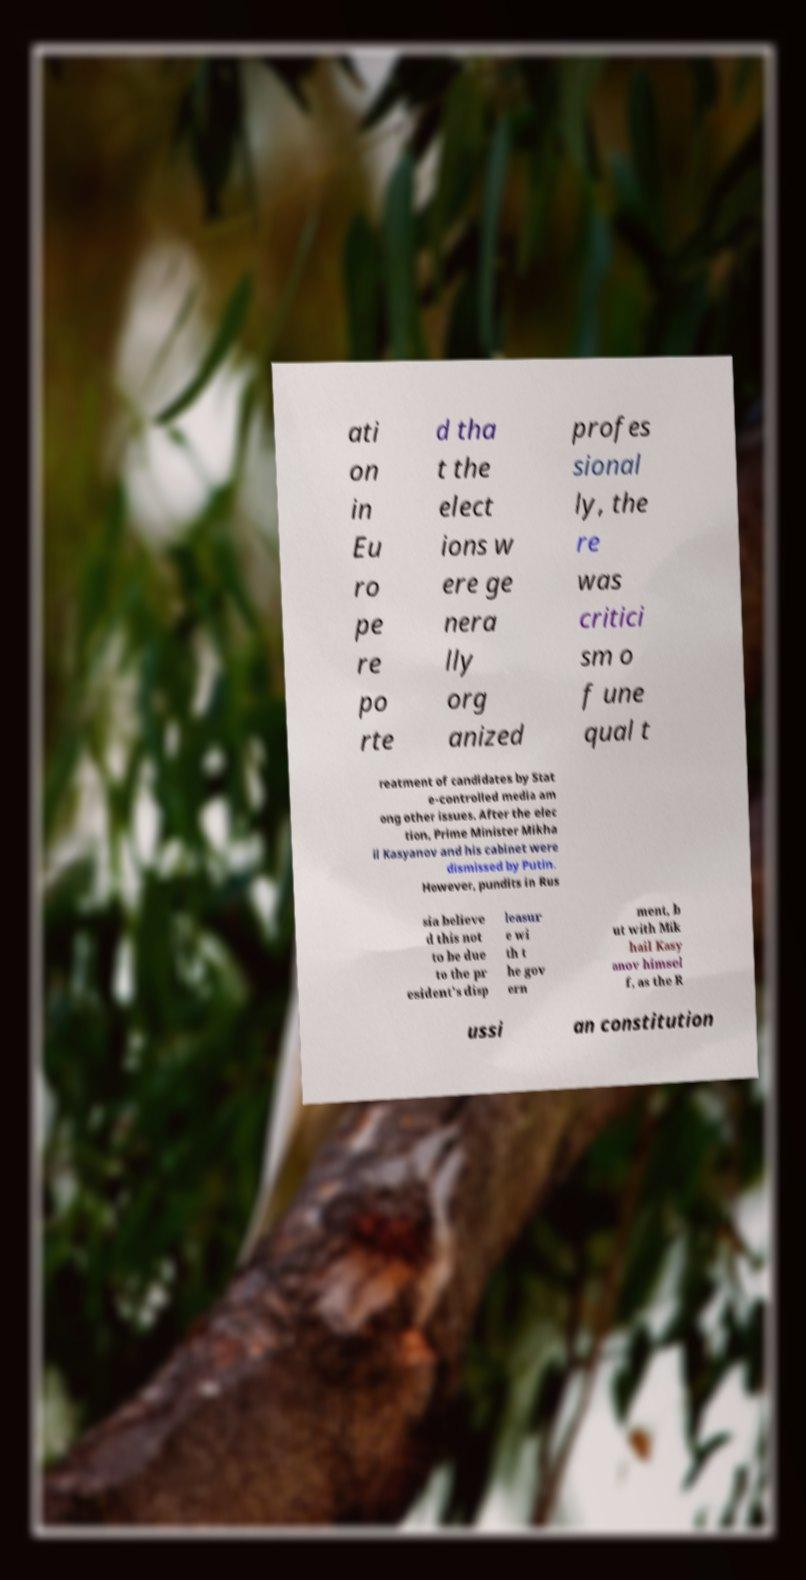There's text embedded in this image that I need extracted. Can you transcribe it verbatim? ati on in Eu ro pe re po rte d tha t the elect ions w ere ge nera lly org anized profes sional ly, the re was critici sm o f une qual t reatment of candidates by Stat e-controlled media am ong other issues. After the elec tion, Prime Minister Mikha il Kasyanov and his cabinet were dismissed by Putin. However, pundits in Rus sia believe d this not to be due to the pr esident's disp leasur e wi th t he gov ern ment, b ut with Mik hail Kasy anov himsel f, as the R ussi an constitution 